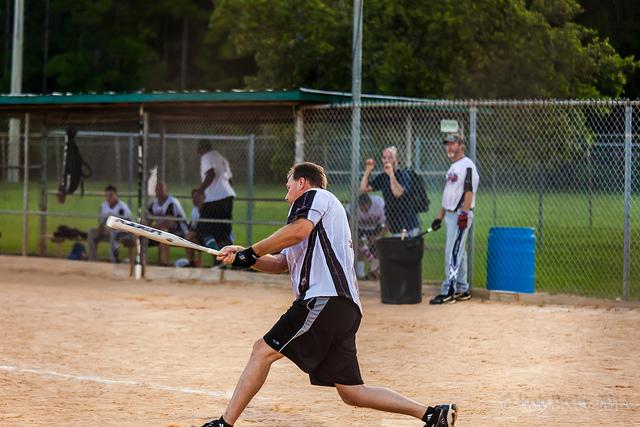What is the man with the bat looking at?
Write a very short answer. Ball. What color socks is the batter wearing?
Quick response, please. Black. What sport is this?
Short answer required. Baseball. What is the blue barrel used for?
Concise answer only. Trash. How many baseball bats are in the picture?
Answer briefly. 1. What is this person holding?
Keep it brief. Bat. What color is the batter's helmet?
Short answer required. No helmet. What are they doing?
Write a very short answer. Baseball. What is behind the batter?
Concise answer only. Nothing. What sport is this man playing?
Short answer required. Baseball. Is this little league baseball?
Short answer required. No. Does the man look happy?
Give a very brief answer. No. What is the motion the batter is making?
Keep it brief. Swinging. What game were the two men playing?
Answer briefly. Baseball. Are the spectators interested in the player's performance?
Short answer required. Yes. What sport is being played?
Quick response, please. Baseball. 